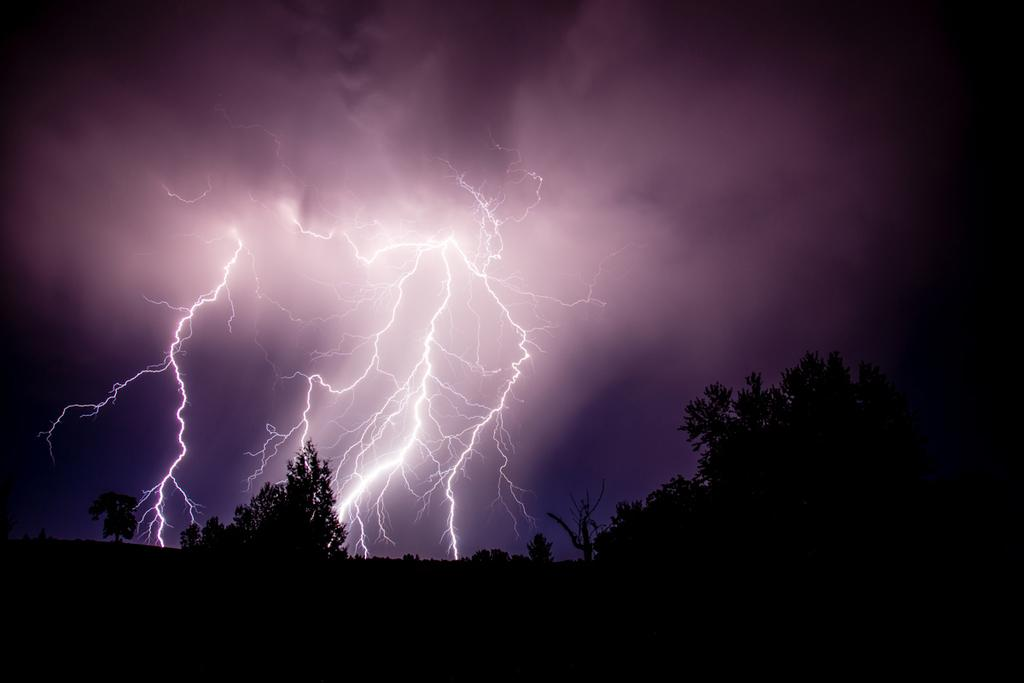What natural phenomenon can be seen in the image? There is lightning in the image. What type of vegetation is present in the image? There are trees in the image. What else can be seen in the image besides lightning and trees? There are other objects in the image. What is visible at the top of the image? The sky is visible at the top of the image. What is the surface at the bottom of the image? There is a black surface at the bottom of the image. Can you see any cherries floating on the lake in the image? There is no lake or cherries present in the image. How many pins are holding the trees in place in the image? There are no pins visible in the image; the trees are standing on their own. 